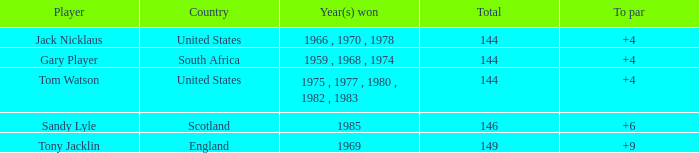What player had a To par smaller than 9 and won in 1985? Sandy Lyle. 